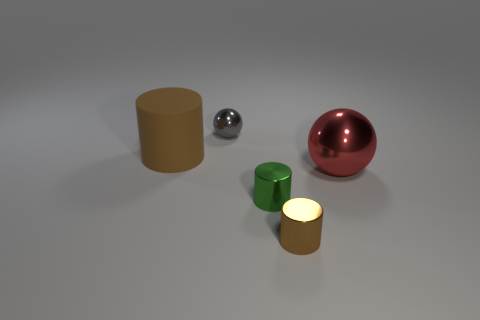Subtract all green cylinders. Subtract all purple spheres. How many cylinders are left? 2 Add 4 tiny purple rubber things. How many objects exist? 9 Subtract all spheres. How many objects are left? 3 Add 5 large brown rubber cylinders. How many large brown rubber cylinders are left? 6 Add 5 blue cubes. How many blue cubes exist? 5 Subtract 0 gray cubes. How many objects are left? 5 Subtract all big gray rubber objects. Subtract all brown metallic cylinders. How many objects are left? 4 